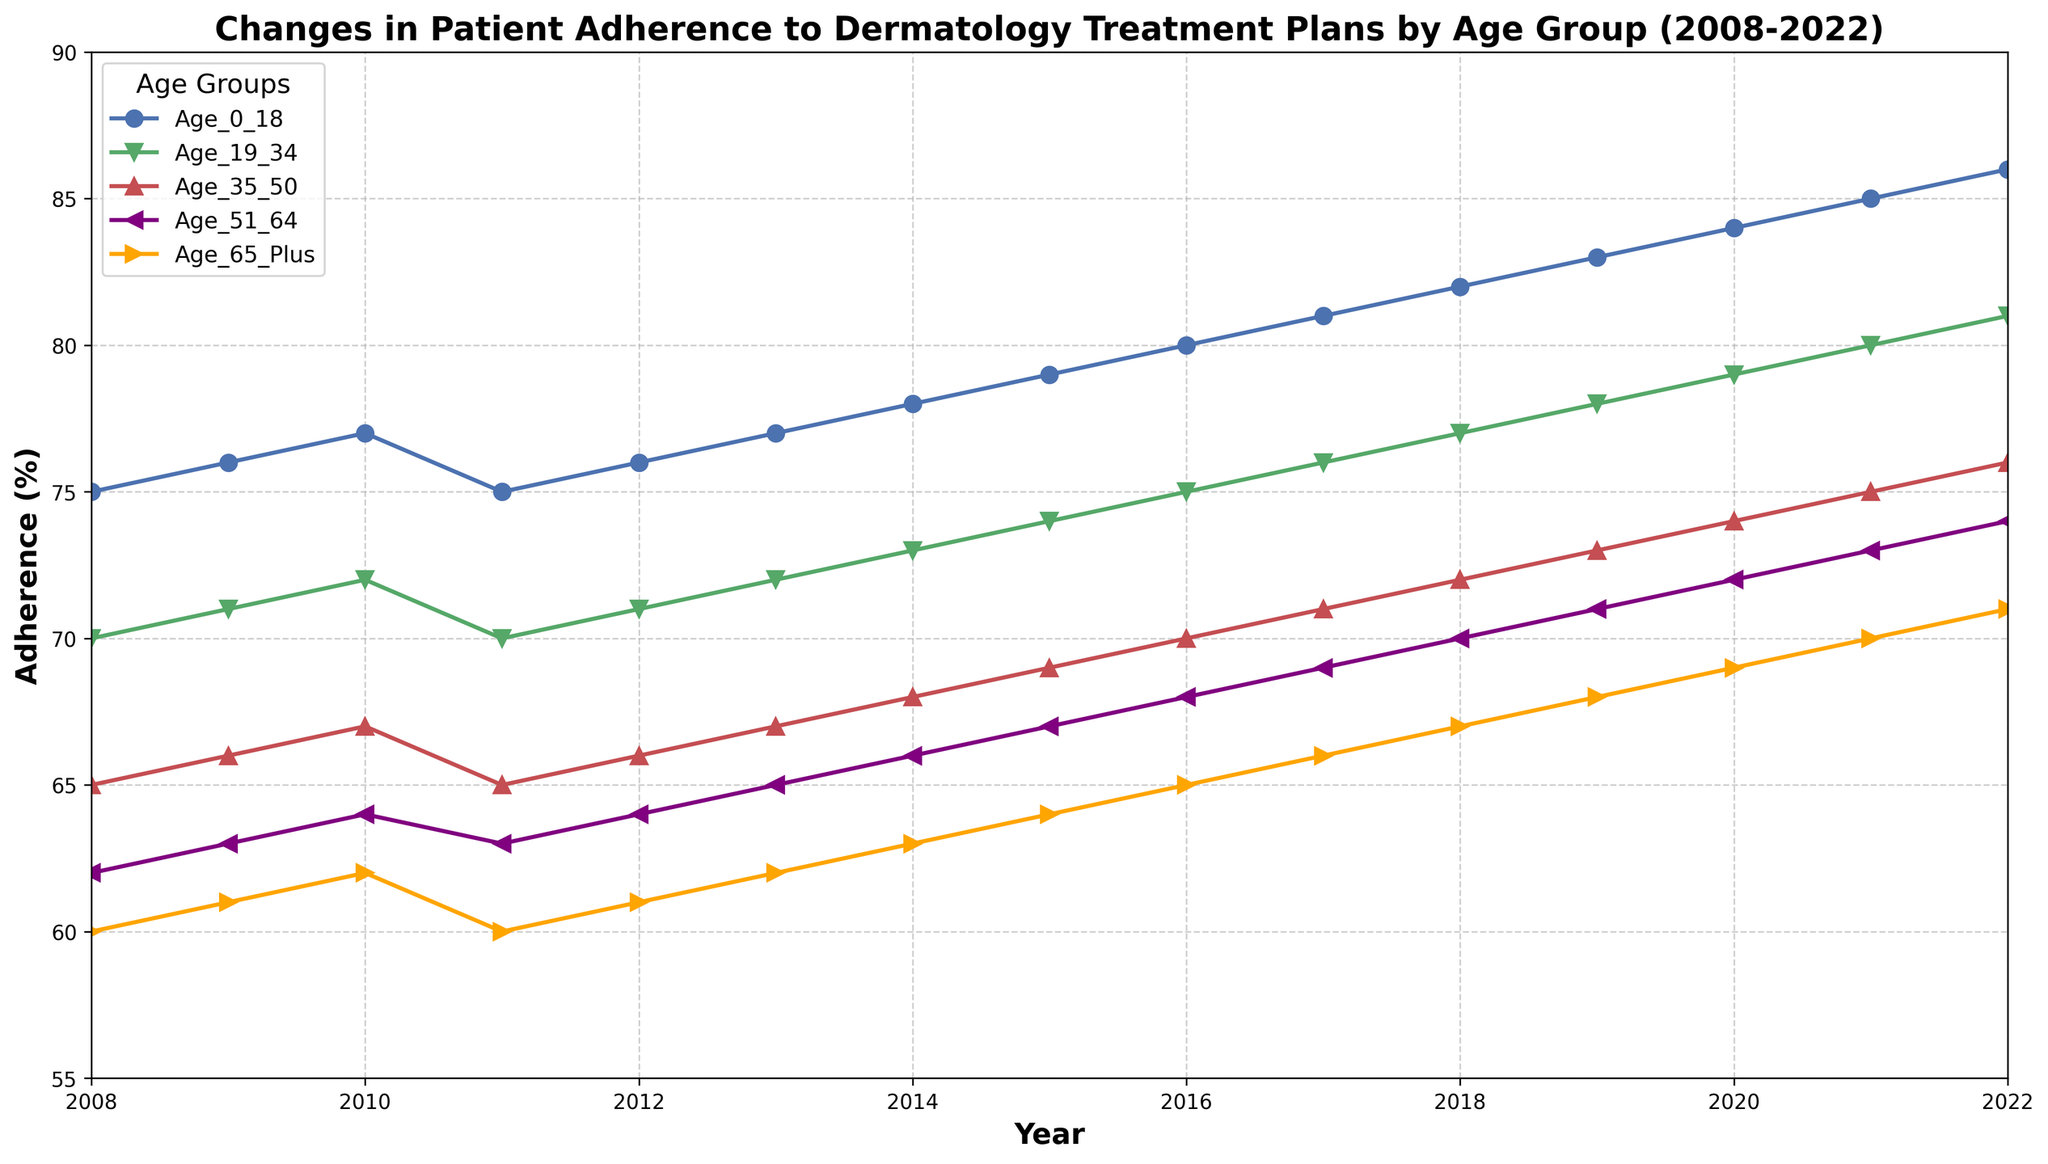What is the adherence percentage for the age group 51-64 in 2010? Locate the 51-64 age group in the legend, which is marked in purple. Follow the purple line to 2010 on the x-axis and note the corresponding y-value.
Answer: 64 Which age group had the highest adherence percentage in 2022? Look at the data points for 2022 for all age groups. Identify the highest y-value.
Answer: Age_0_18 By how much did adherence improve for the age group 19-34 from 2008 to 2022? Find the adherence percentages for the age group 19-34 in 2008 and 2022. Subtract the 2008 value from the 2022 value (81-70).
Answer: 11 Which age group showed the most consistent adherence percentage over the years? Compare the adherence trends for each age group. Identify the one with the smallest fluctuations or change.
Answer: Age_65_Plus What is the average adherence percentage for the age group 35-50 over the 15 years? Sum the adherence percentages for the age group 35-50 for each year, then divide by the number of years (15).
Answer: (65+66+67+65+66+67+68+69+70+71+72+73+74+75+76)/15 = 69.4 Which two age groups have lines that cross each other, indicating changes in their adherence trends relative to one another? Look for intersections of the plotted lines for different age groups over the years. Identify which groups cross each other.
Answer: Age_51_64 and Age_65_Plus Has the adherence percentage for the age group 0-18 always been higher than for the age group 65_Plus over the 15 years? Compare the y-values for the age groups 0-18 and 65_Plus for each year from 2008 to 2022 to see if 0-18 is always higher.
Answer: Yes What was the year-on-year percentage change in adherence for the age group 51-64 between 2020 and 2021? Find the adherence values for the age group 51-64 in 2020 and 2021. Calculate the change (73-72), then use the formula [(new-old)/old]*100 to get the percentage change.
Answer: (73-72)/72 * 100 ≈ 1.39% Which year showed a decrease in adherence percentage for at least one age group compared to the previous year? Identify the years from 2008 to 2022. Check each year to see if there is any drop in adherence for any age group compared to the previous year.
Answer: 2011 